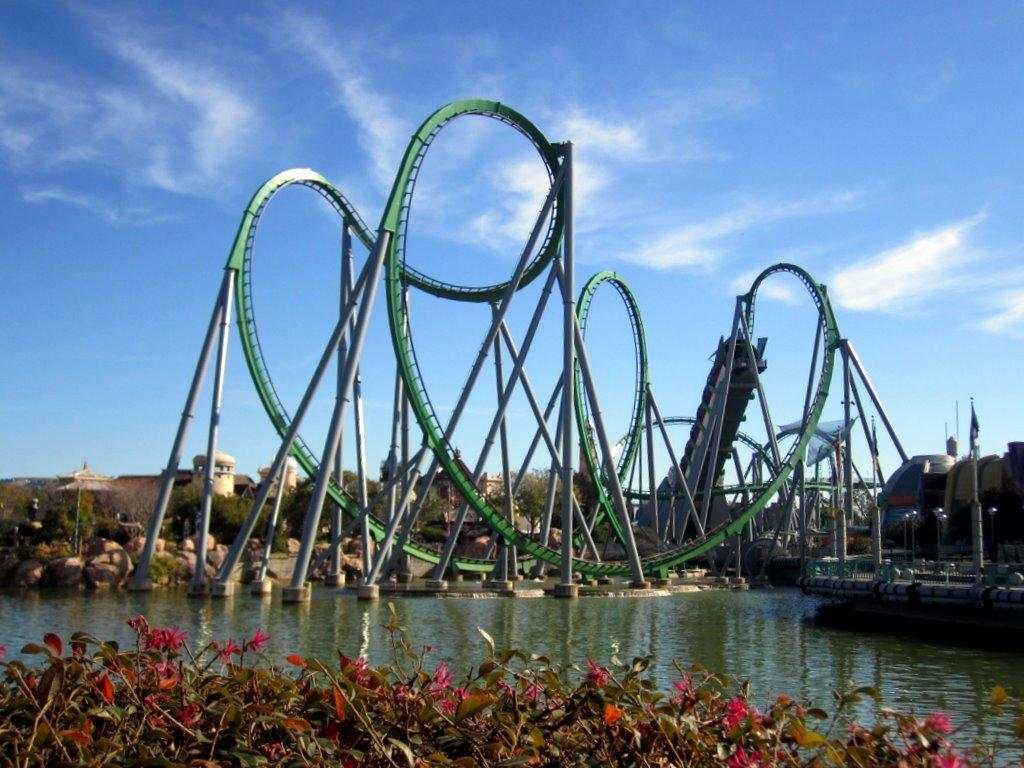What can be seen in the sky in the image? The sky is visible in the image, but no specific details about the sky are mentioned in the facts. What type of ride is present in the image? There is a rollercoaster in the image. What type of natural features can be seen in the image? Rocks, trees, plants, flowers, and a river are present in the image. Can you see any jellyfish swimming in the river in the image? There are no jellyfish present in the image; the river is not mentioned as having any specific aquatic life. Is there a street visible in the image? There is no mention of a street in the provided facts, so it cannot be determined if one is present in the image. 